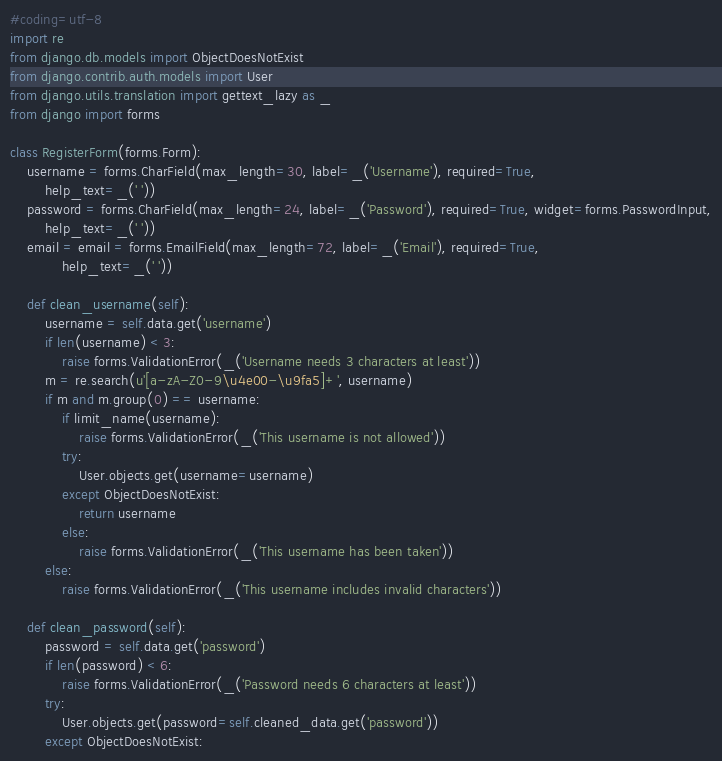Convert code to text. <code><loc_0><loc_0><loc_500><loc_500><_Python_>#coding=utf-8
import re
from django.db.models import ObjectDoesNotExist
from django.contrib.auth.models import User
from django.utils.translation import gettext_lazy as _
from django import forms

class RegisterForm(forms.Form):
	username = forms.CharField(max_length=30, label=_('Username'), required=True,
		help_text=_(' '))
	password = forms.CharField(max_length=24, label=_('Password'), required=True, widget=forms.PasswordInput,
		help_text=_(' '))
	email = email = forms.EmailField(max_length=72, label=_('Email'), required=True,
			help_text=_(' '))

	def clean_username(self):
		username = self.data.get('username')
		if len(username) < 3:
			raise forms.ValidationError(_('Username needs 3 characters at least'))
		m = re.search(u'[a-zA-Z0-9\u4e00-\u9fa5]+', username)
		if m and m.group(0) == username:
			if limit_name(username):
				raise forms.ValidationError(_('This username is not allowed'))
			try:
				User.objects.get(username=username)
			except ObjectDoesNotExist:
				return username
			else:
				raise forms.ValidationError(_('This username has been taken'))
		else:
			raise forms.ValidationError(_('This username includes invalid characters'))
		
	def clean_password(self):
		password = self.data.get('password')
		if len(password) < 6:
			raise forms.ValidationError(_('Password needs 6 characters at least'))
		try:
			User.objects.get(password=self.cleaned_data.get('password'))
		except ObjectDoesNotExist:</code> 